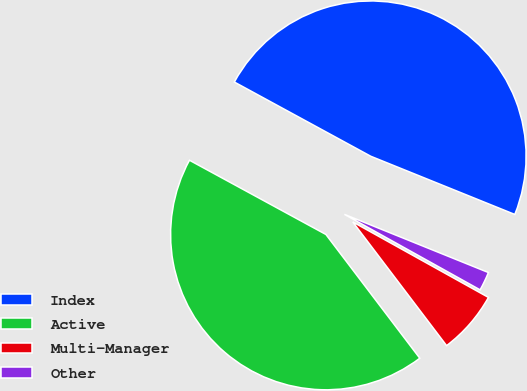Convert chart to OTSL. <chart><loc_0><loc_0><loc_500><loc_500><pie_chart><fcel>Index<fcel>Active<fcel>Multi-Manager<fcel>Other<nl><fcel>48.18%<fcel>43.26%<fcel>6.59%<fcel>1.97%<nl></chart> 